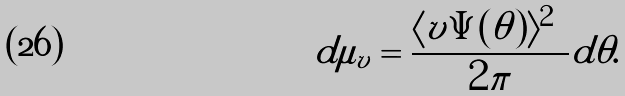<formula> <loc_0><loc_0><loc_500><loc_500>d \mu _ { v } = \frac { \langle v | \Psi ( \theta ) \rangle | ^ { 2 } } { 2 \pi } d \theta .</formula> 